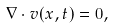<formula> <loc_0><loc_0><loc_500><loc_500>\nabla \cdot { v } ( { x } , t ) = 0 ,</formula> 